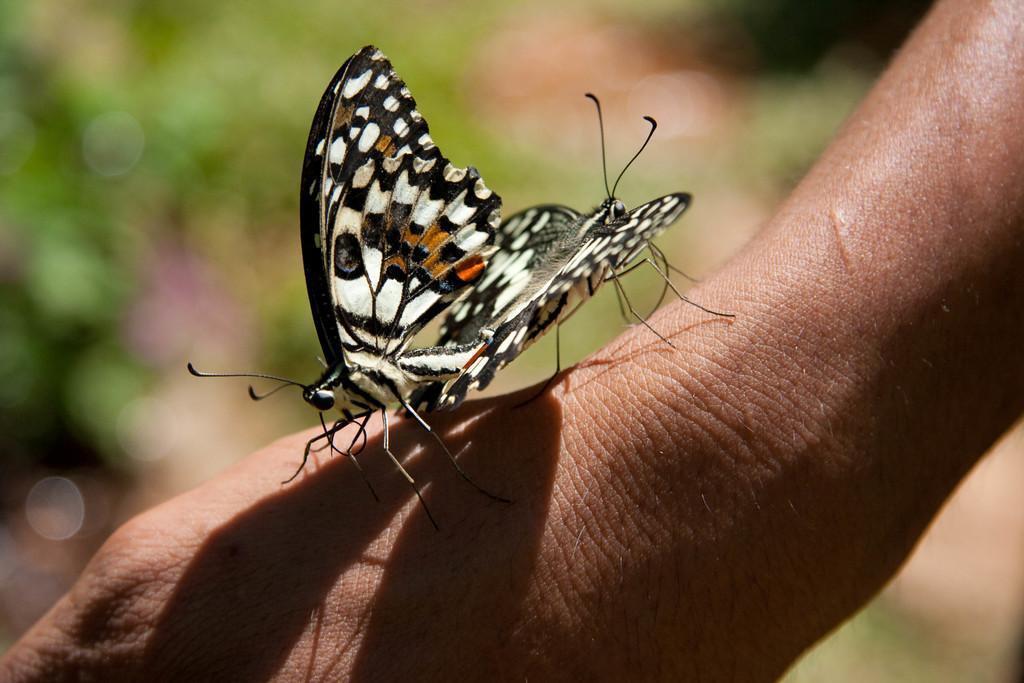Can you describe this image briefly? In this picture there are two butterflies standing on the person's hand. In the back we can see green grass. 